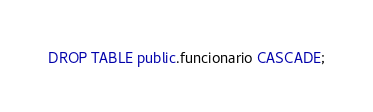<code> <loc_0><loc_0><loc_500><loc_500><_SQL_>DROP TABLE public.funcionario CASCADE;</code> 